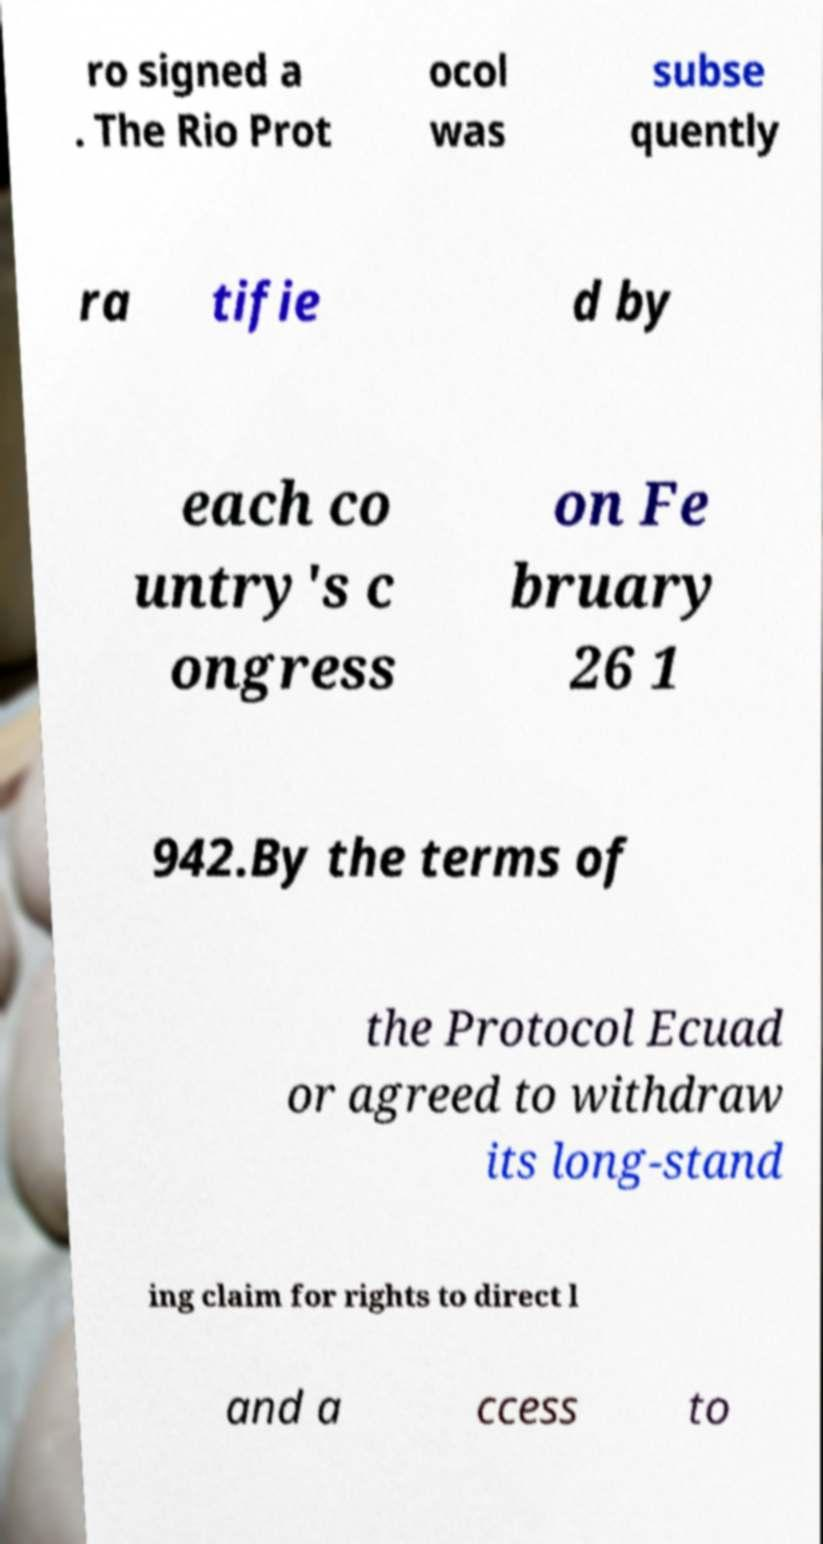Please read and relay the text visible in this image. What does it say? ro signed a . The Rio Prot ocol was subse quently ra tifie d by each co untry's c ongress on Fe bruary 26 1 942.By the terms of the Protocol Ecuad or agreed to withdraw its long-stand ing claim for rights to direct l and a ccess to 